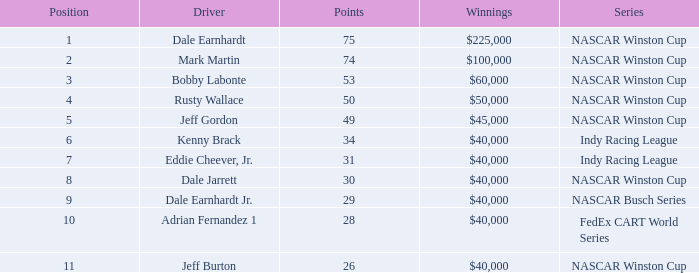At which standing did the driver gain 31 points? 7.0. 